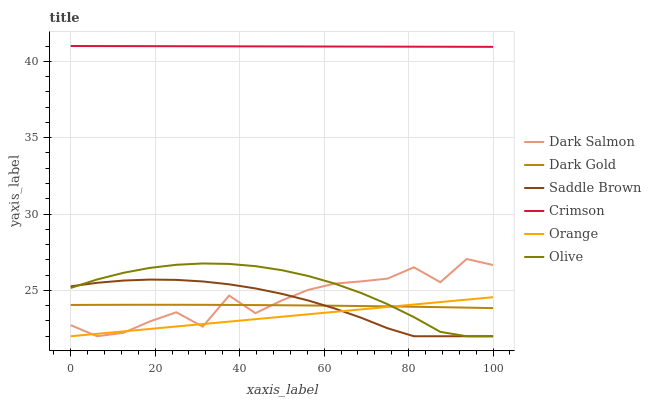Does Dark Gold have the minimum area under the curve?
Answer yes or no. No. Does Dark Gold have the maximum area under the curve?
Answer yes or no. No. Is Dark Gold the smoothest?
Answer yes or no. No. Is Dark Gold the roughest?
Answer yes or no. No. Does Dark Gold have the lowest value?
Answer yes or no. No. Does Dark Salmon have the highest value?
Answer yes or no. No. Is Saddle Brown less than Crimson?
Answer yes or no. Yes. Is Crimson greater than Dark Salmon?
Answer yes or no. Yes. Does Saddle Brown intersect Crimson?
Answer yes or no. No. 